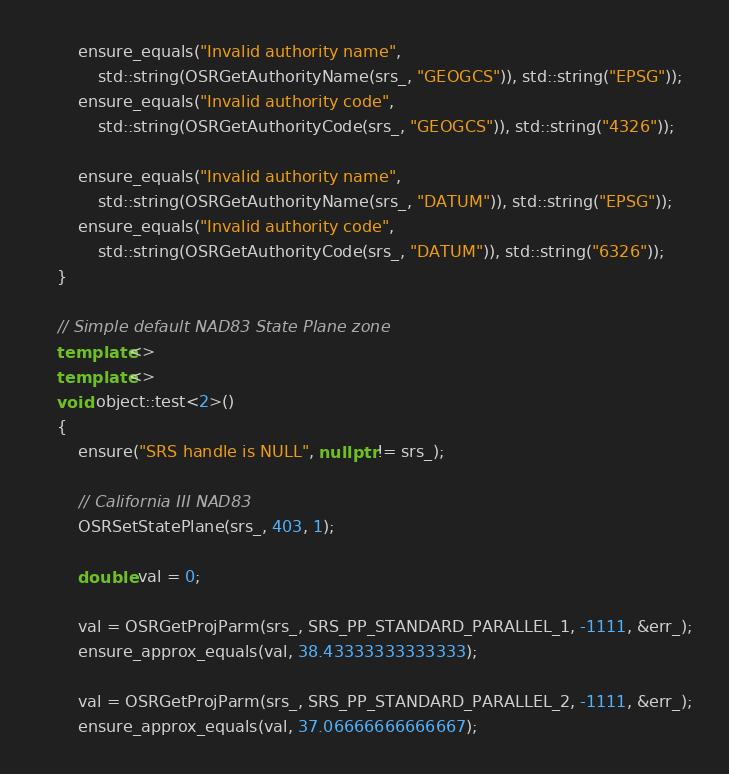Convert code to text. <code><loc_0><loc_0><loc_500><loc_500><_C++_>
        ensure_equals("Invalid authority name",
            std::string(OSRGetAuthorityName(srs_, "GEOGCS")), std::string("EPSG"));
        ensure_equals("Invalid authority code",
            std::string(OSRGetAuthorityCode(srs_, "GEOGCS")), std::string("4326"));

        ensure_equals("Invalid authority name",
            std::string(OSRGetAuthorityName(srs_, "DATUM")), std::string("EPSG"));
        ensure_equals("Invalid authority code",
            std::string(OSRGetAuthorityCode(srs_, "DATUM")), std::string("6326"));
    }

    // Simple default NAD83 State Plane zone
    template<>
    template<>
    void object::test<2>()
    {
        ensure("SRS handle is NULL", nullptr != srs_);

        // California III NAD83
        OSRSetStatePlane(srs_, 403, 1);

        double val = 0;

        val = OSRGetProjParm(srs_, SRS_PP_STANDARD_PARALLEL_1, -1111, &err_);
        ensure_approx_equals(val, 38.43333333333333);

        val = OSRGetProjParm(srs_, SRS_PP_STANDARD_PARALLEL_2, -1111, &err_);
        ensure_approx_equals(val, 37.06666666666667);
</code> 